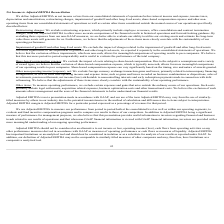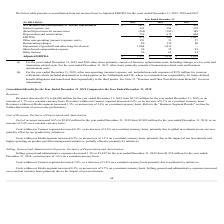Looking at Nielsen Nv's financial data, please calculate: What is the interest coverage ratio in 2019? Based on the calculation: 472/391, the result is 1.21. This is based on the information: "EBITDA 472 167 1,827 Interest expense, net 391 386 370..." The key data points involved are: 391, 472. Also, can you calculate: What is the percentage change in the net loss from 2018 to 2019? To answer this question, I need to perform calculations using the financial data. The calculation is: (415-712)/712, which equals -41.71 (percentage). This is based on the information: ") attributable to Nielsen shareholders $ (415) $ (712) $ 429 me/(loss) attributable to Nielsen shareholders $ (415) $ (712) $ 429..." The key data points involved are: 415, 712. Also, can you calculate: What is the percentage change in the adjusted EBITDA from 2018 to 2019? To answer this question, I need to perform calculations using the financial data. The calculation is: (1,853-1,850)/1,850, which equals 0.16 (percentage). This is based on the information: "Adjusted EBITDA $ 1,853 $ 1,850 $ 2,024 Adjusted EBITDA $ 1,853 $ 1,850 $ 2,024..." The key data points involved are: 1,850, 1,853. Also, How does share-based compensation expense vary? based on the timing, size and nature of awards granted. The document states: "based compensation expense can vary significantly based on the timing, size and nature of awards granted...." Also, When should adjusted EBITDA not be considered? in isolation or as a substitute for analysis of our results as reported under GAAP. The document states: "s an analytical tool and should not be considered in isolation or as a substitute for analysis of our results as reported under GAAP. In addition, our..." Also, What is the EBITDA for 2019, 2018 and 2017 respectively? The document contains multiple relevant values: 472, 167, 1,827 (in millions). From the document: "EBITDA 472 167 1,827 EBITDA 472 167 1,827 EBITDA 472 167 1,827..." 